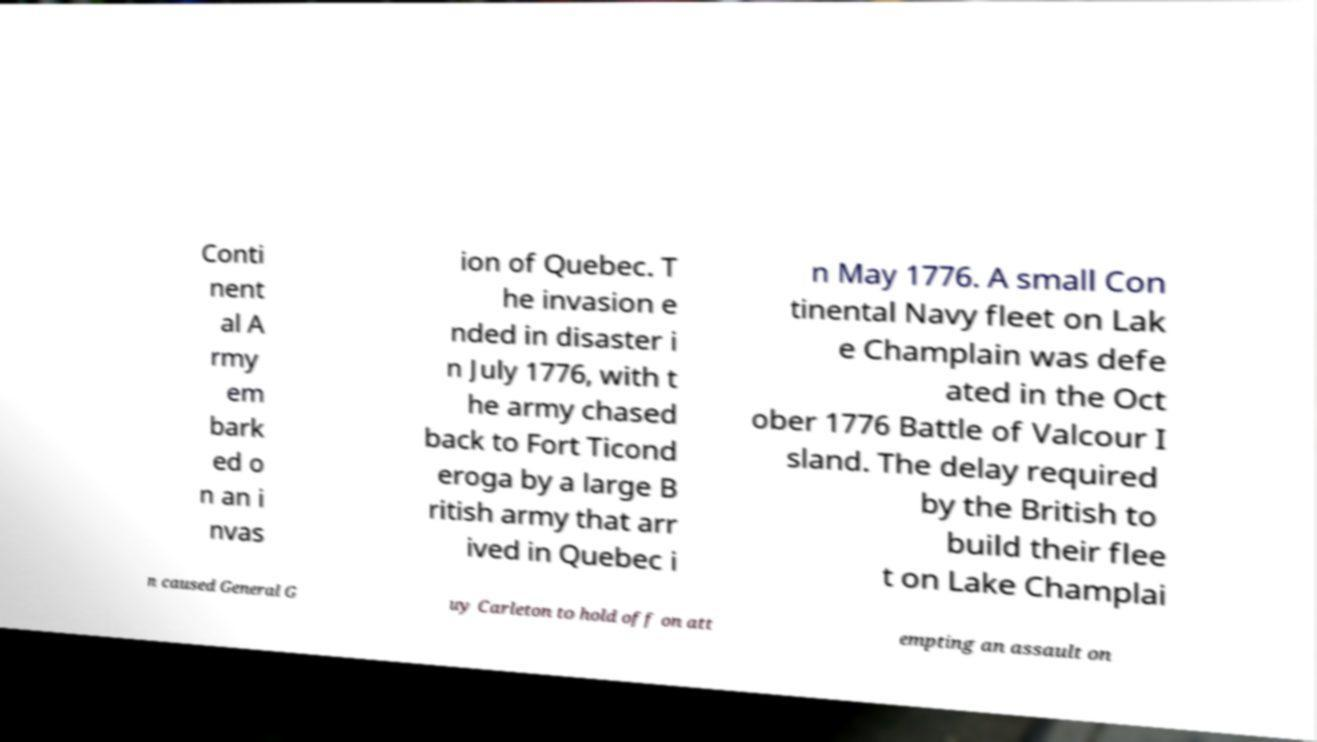Please read and relay the text visible in this image. What does it say? Conti nent al A rmy em bark ed o n an i nvas ion of Quebec. T he invasion e nded in disaster i n July 1776, with t he army chased back to Fort Ticond eroga by a large B ritish army that arr ived in Quebec i n May 1776. A small Con tinental Navy fleet on Lak e Champlain was defe ated in the Oct ober 1776 Battle of Valcour I sland. The delay required by the British to build their flee t on Lake Champlai n caused General G uy Carleton to hold off on att empting an assault on 